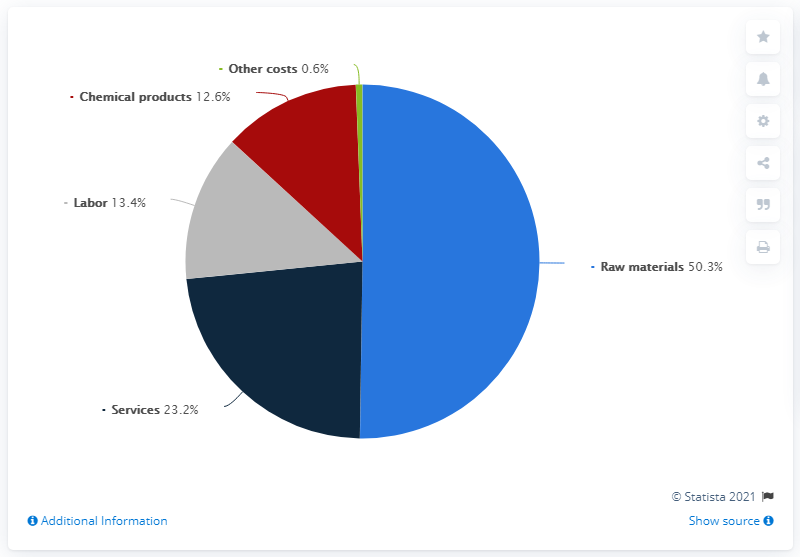List a handful of essential elements in this visual. The combined percentage of the top three sections is 86.9%. In the image, the blue pie represents raw materials. 